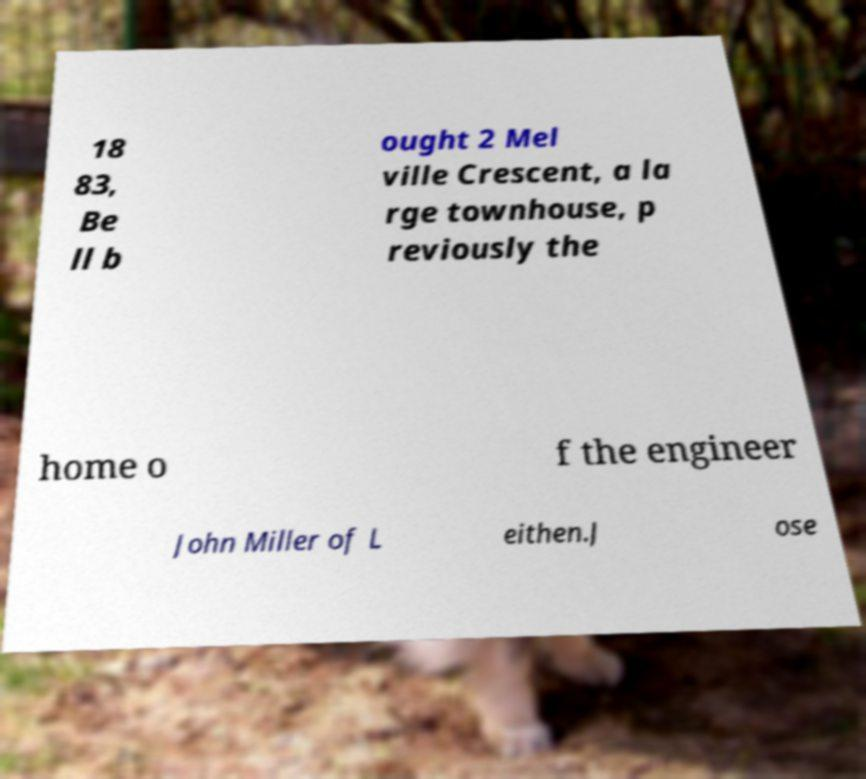Can you read and provide the text displayed in the image?This photo seems to have some interesting text. Can you extract and type it out for me? 18 83, Be ll b ought 2 Mel ville Crescent, a la rge townhouse, p reviously the home o f the engineer John Miller of L eithen.J ose 